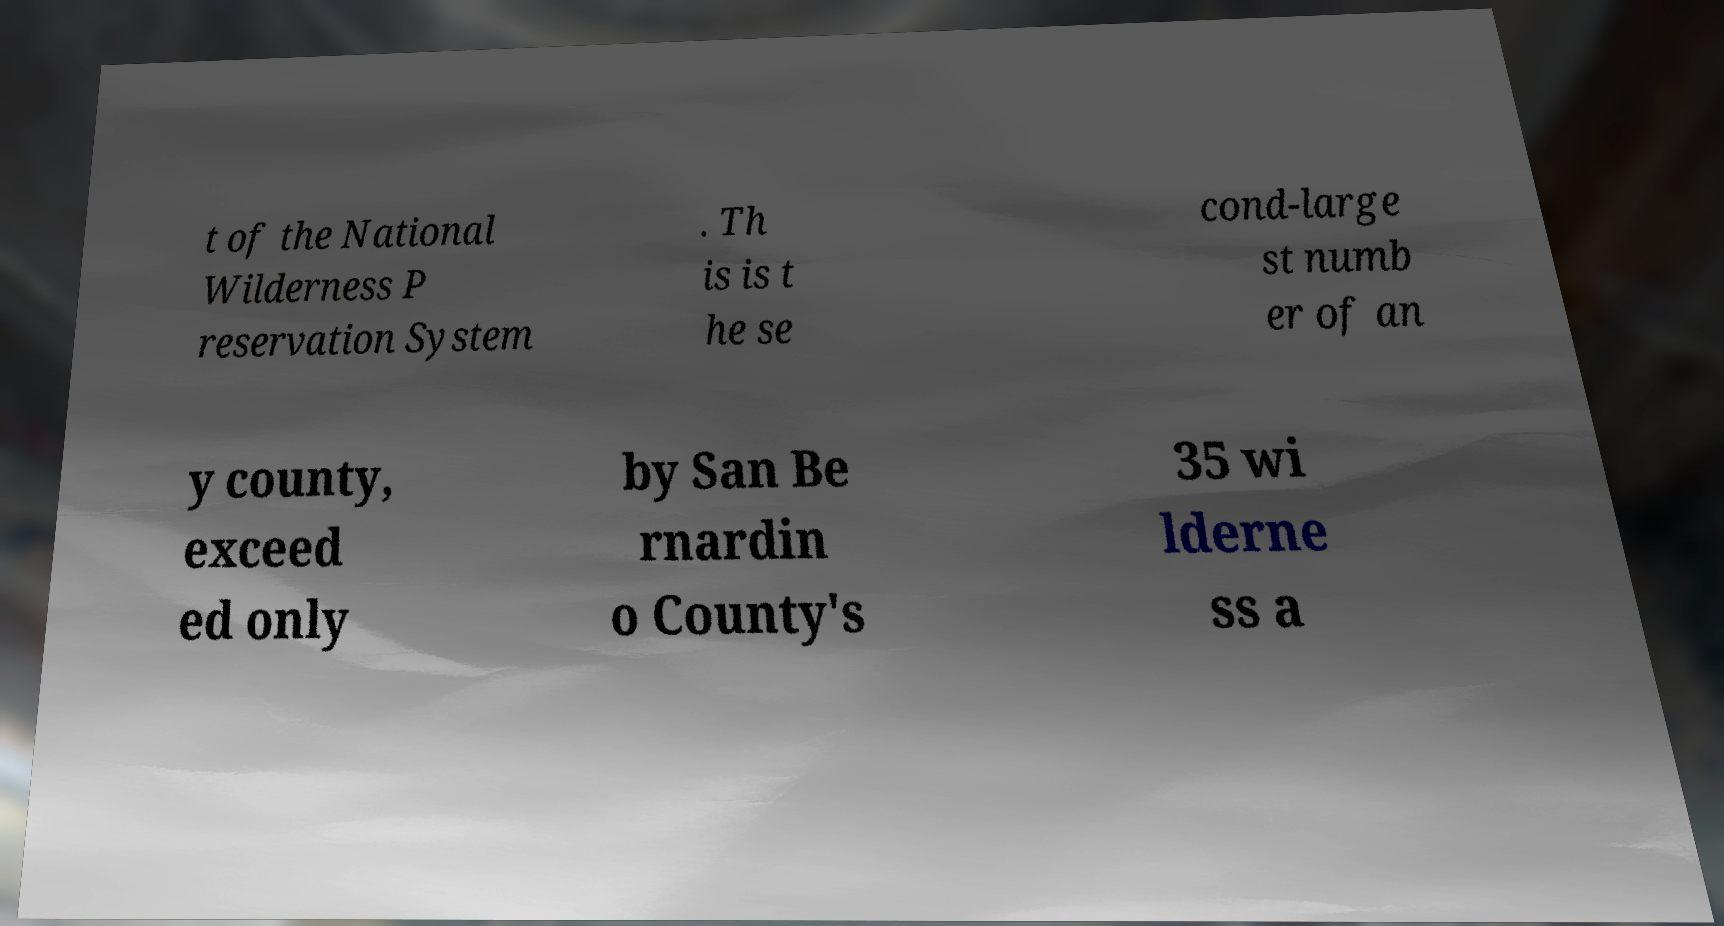Please read and relay the text visible in this image. What does it say? t of the National Wilderness P reservation System . Th is is t he se cond-large st numb er of an y county, exceed ed only by San Be rnardin o County's 35 wi lderne ss a 